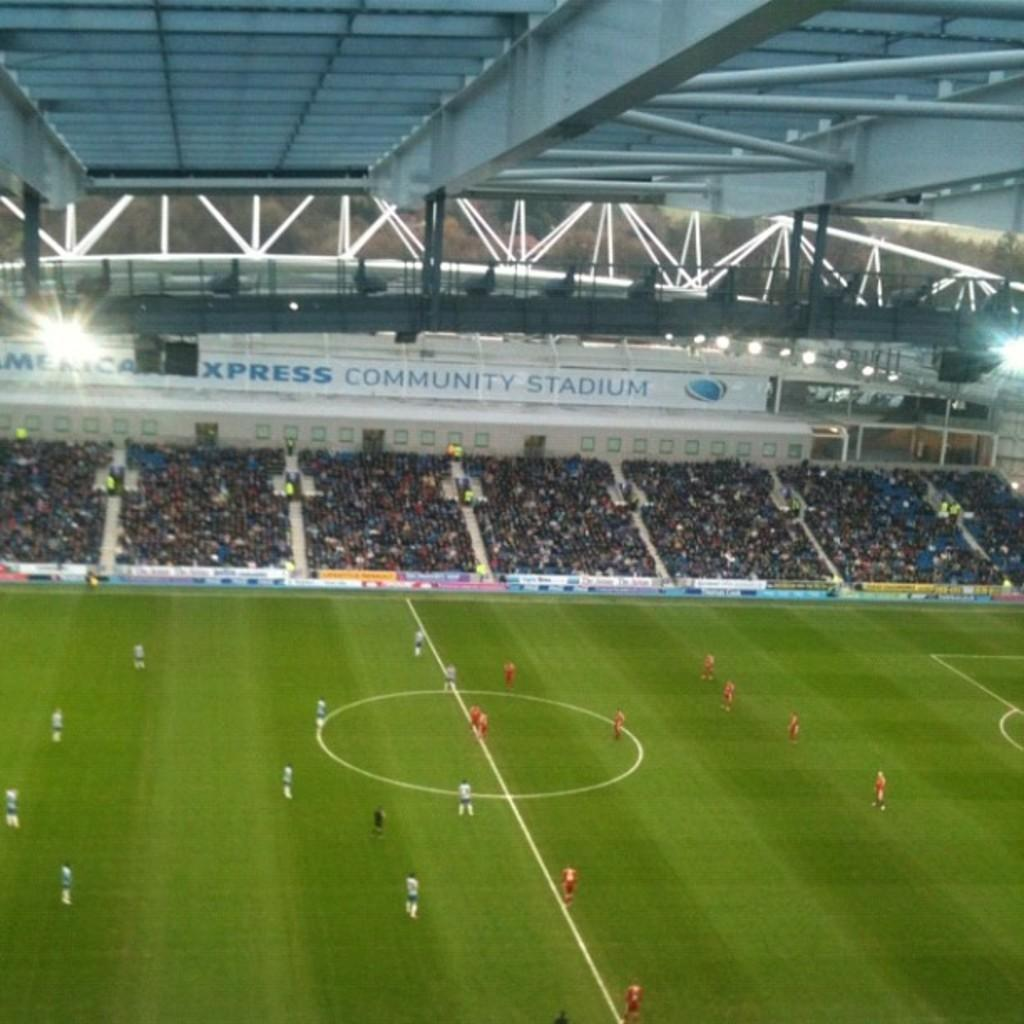<image>
Write a terse but informative summary of the picture. Soccer players on the field of a packed American Express Community Stadium. 